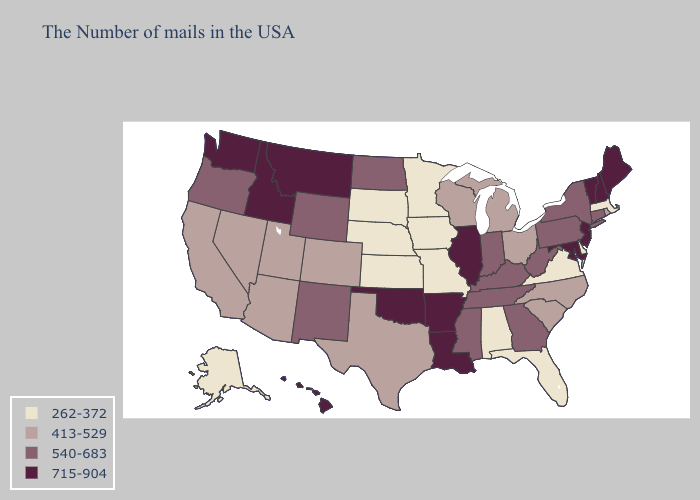Name the states that have a value in the range 715-904?
Be succinct. Maine, New Hampshire, Vermont, New Jersey, Maryland, Illinois, Louisiana, Arkansas, Oklahoma, Montana, Idaho, Washington, Hawaii. What is the lowest value in the Northeast?
Answer briefly. 262-372. Does Michigan have the lowest value in the USA?
Short answer required. No. Name the states that have a value in the range 262-372?
Short answer required. Massachusetts, Delaware, Virginia, Florida, Alabama, Missouri, Minnesota, Iowa, Kansas, Nebraska, South Dakota, Alaska. What is the highest value in the South ?
Concise answer only. 715-904. What is the value of Oklahoma?
Answer briefly. 715-904. Name the states that have a value in the range 413-529?
Quick response, please. Rhode Island, North Carolina, South Carolina, Ohio, Michigan, Wisconsin, Texas, Colorado, Utah, Arizona, Nevada, California. Does Vermont have the highest value in the USA?
Answer briefly. Yes. Which states have the lowest value in the USA?
Write a very short answer. Massachusetts, Delaware, Virginia, Florida, Alabama, Missouri, Minnesota, Iowa, Kansas, Nebraska, South Dakota, Alaska. Name the states that have a value in the range 715-904?
Short answer required. Maine, New Hampshire, Vermont, New Jersey, Maryland, Illinois, Louisiana, Arkansas, Oklahoma, Montana, Idaho, Washington, Hawaii. What is the value of Georgia?
Write a very short answer. 540-683. What is the highest value in the Northeast ?
Write a very short answer. 715-904. What is the value of Louisiana?
Be succinct. 715-904. What is the highest value in states that border Rhode Island?
Write a very short answer. 540-683. Name the states that have a value in the range 413-529?
Quick response, please. Rhode Island, North Carolina, South Carolina, Ohio, Michigan, Wisconsin, Texas, Colorado, Utah, Arizona, Nevada, California. 